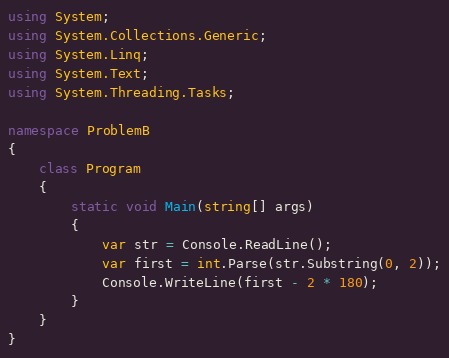<code> <loc_0><loc_0><loc_500><loc_500><_C#_>using System;
using System.Collections.Generic;
using System.Linq;
using System.Text;
using System.Threading.Tasks;
 
namespace ProblemB
{
    class Program
    {
        static void Main(string[] args)
        {
            var str = Console.ReadLine();
            var first = int.Parse(str.Substring(0, 2));
            Console.WriteLine(first - 2 * 180);
        }
    }
}</code> 